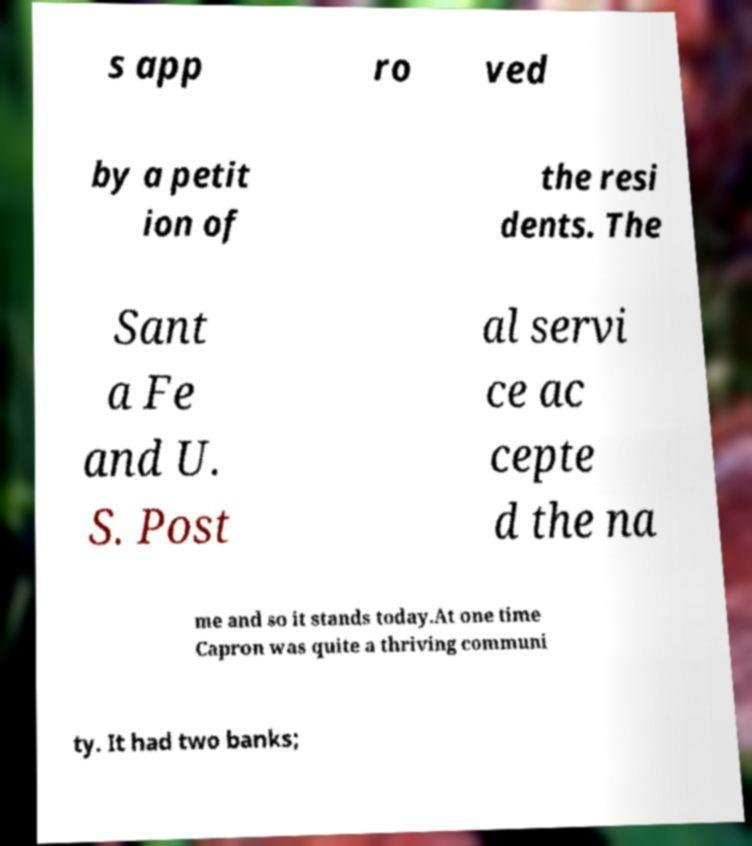Can you accurately transcribe the text from the provided image for me? s app ro ved by a petit ion of the resi dents. The Sant a Fe and U. S. Post al servi ce ac cepte d the na me and so it stands today.At one time Capron was quite a thriving communi ty. It had two banks; 